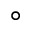<formula> <loc_0><loc_0><loc_500><loc_500>^ { \circ }</formula> 